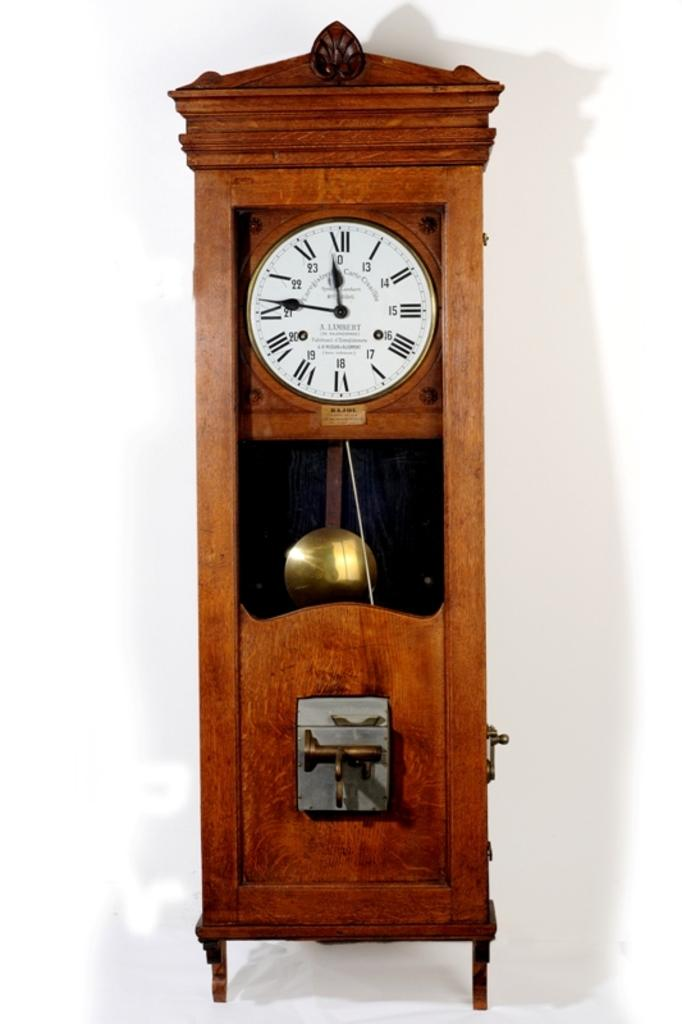Provide a one-sentence caption for the provided image. An antique style wall clock that is displaying the time of 11:46. 